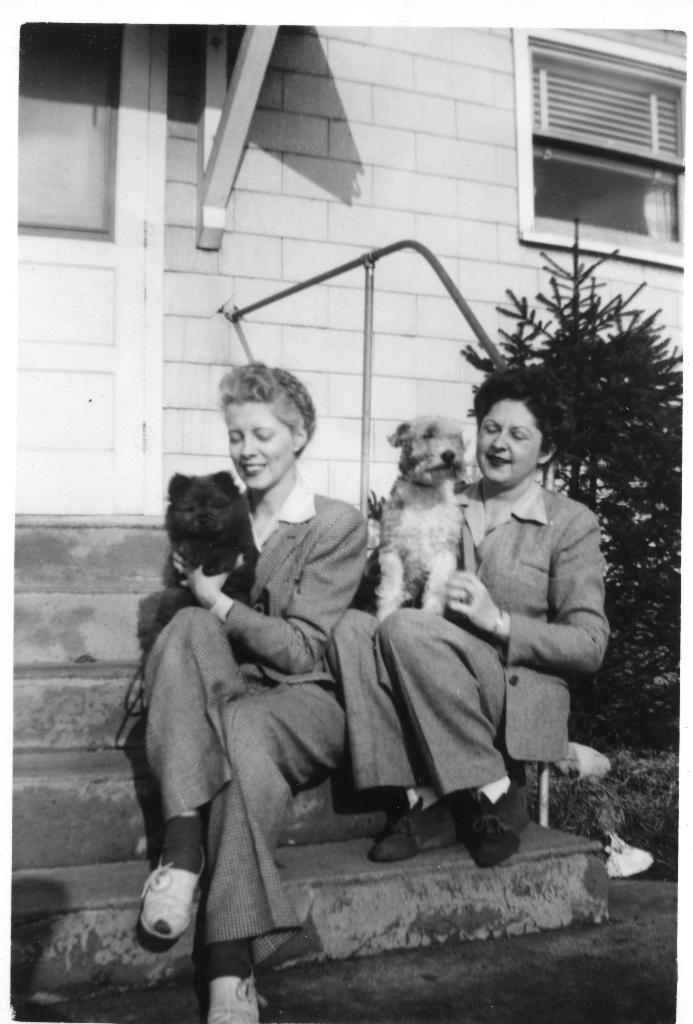How many women are in the image? There are two women in the image. What are the women doing in the image? The women are seated on the steps and holding their dogs. What can be seen in the background of the image? There is a plant, a metal rod, and a building visible in the background. What type of bead is the woman wearing around her neck in the image? There is no bead visible around the neck of the women in the image. Can you tell me how many wrens are perched on the metal rod in the background? There are no wrens present in the image; the metal rod is in the background, but no birds are visible. 